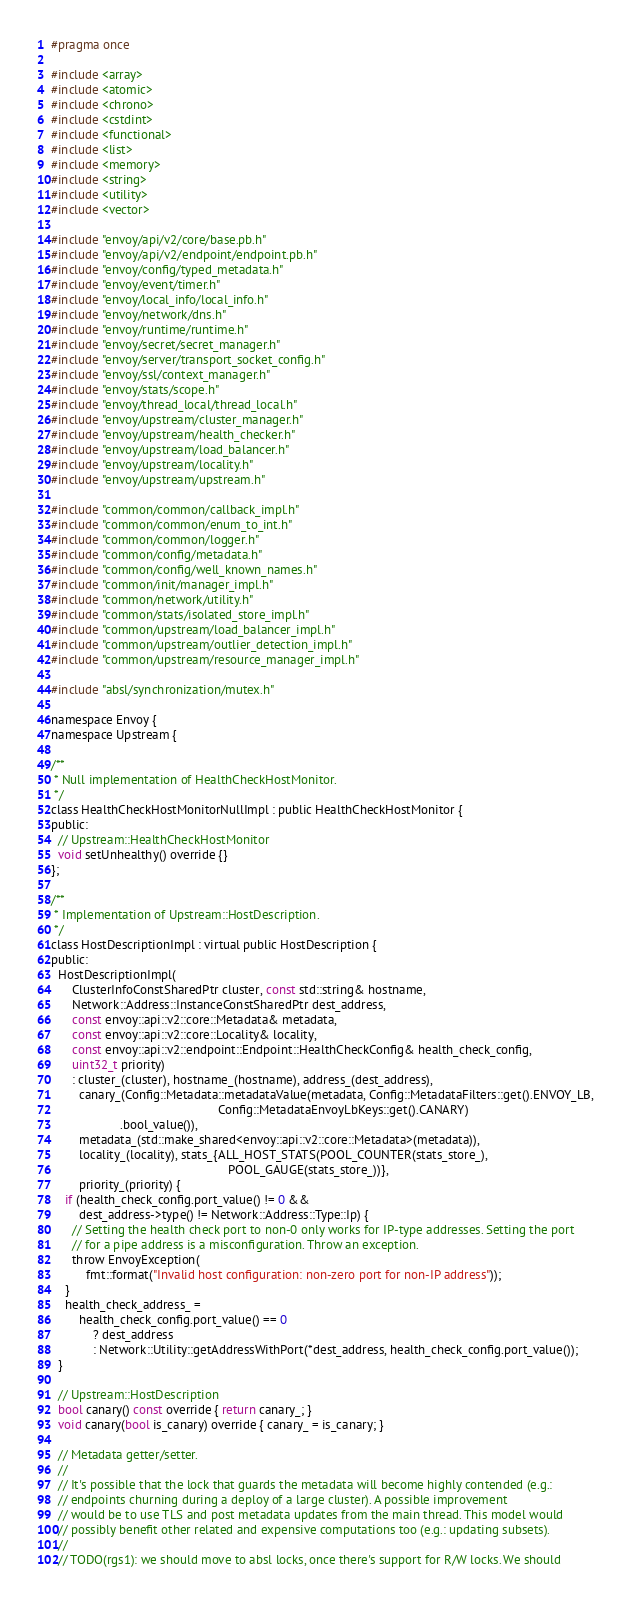<code> <loc_0><loc_0><loc_500><loc_500><_C_>#pragma once

#include <array>
#include <atomic>
#include <chrono>
#include <cstdint>
#include <functional>
#include <list>
#include <memory>
#include <string>
#include <utility>
#include <vector>

#include "envoy/api/v2/core/base.pb.h"
#include "envoy/api/v2/endpoint/endpoint.pb.h"
#include "envoy/config/typed_metadata.h"
#include "envoy/event/timer.h"
#include "envoy/local_info/local_info.h"
#include "envoy/network/dns.h"
#include "envoy/runtime/runtime.h"
#include "envoy/secret/secret_manager.h"
#include "envoy/server/transport_socket_config.h"
#include "envoy/ssl/context_manager.h"
#include "envoy/stats/scope.h"
#include "envoy/thread_local/thread_local.h"
#include "envoy/upstream/cluster_manager.h"
#include "envoy/upstream/health_checker.h"
#include "envoy/upstream/load_balancer.h"
#include "envoy/upstream/locality.h"
#include "envoy/upstream/upstream.h"

#include "common/common/callback_impl.h"
#include "common/common/enum_to_int.h"
#include "common/common/logger.h"
#include "common/config/metadata.h"
#include "common/config/well_known_names.h"
#include "common/init/manager_impl.h"
#include "common/network/utility.h"
#include "common/stats/isolated_store_impl.h"
#include "common/upstream/load_balancer_impl.h"
#include "common/upstream/outlier_detection_impl.h"
#include "common/upstream/resource_manager_impl.h"

#include "absl/synchronization/mutex.h"

namespace Envoy {
namespace Upstream {

/**
 * Null implementation of HealthCheckHostMonitor.
 */
class HealthCheckHostMonitorNullImpl : public HealthCheckHostMonitor {
public:
  // Upstream::HealthCheckHostMonitor
  void setUnhealthy() override {}
};

/**
 * Implementation of Upstream::HostDescription.
 */
class HostDescriptionImpl : virtual public HostDescription {
public:
  HostDescriptionImpl(
      ClusterInfoConstSharedPtr cluster, const std::string& hostname,
      Network::Address::InstanceConstSharedPtr dest_address,
      const envoy::api::v2::core::Metadata& metadata,
      const envoy::api::v2::core::Locality& locality,
      const envoy::api::v2::endpoint::Endpoint::HealthCheckConfig& health_check_config,
      uint32_t priority)
      : cluster_(cluster), hostname_(hostname), address_(dest_address),
        canary_(Config::Metadata::metadataValue(metadata, Config::MetadataFilters::get().ENVOY_LB,
                                                Config::MetadataEnvoyLbKeys::get().CANARY)
                    .bool_value()),
        metadata_(std::make_shared<envoy::api::v2::core::Metadata>(metadata)),
        locality_(locality), stats_{ALL_HOST_STATS(POOL_COUNTER(stats_store_),
                                                   POOL_GAUGE(stats_store_))},
        priority_(priority) {
    if (health_check_config.port_value() != 0 &&
        dest_address->type() != Network::Address::Type::Ip) {
      // Setting the health check port to non-0 only works for IP-type addresses. Setting the port
      // for a pipe address is a misconfiguration. Throw an exception.
      throw EnvoyException(
          fmt::format("Invalid host configuration: non-zero port for non-IP address"));
    }
    health_check_address_ =
        health_check_config.port_value() == 0
            ? dest_address
            : Network::Utility::getAddressWithPort(*dest_address, health_check_config.port_value());
  }

  // Upstream::HostDescription
  bool canary() const override { return canary_; }
  void canary(bool is_canary) override { canary_ = is_canary; }

  // Metadata getter/setter.
  //
  // It's possible that the lock that guards the metadata will become highly contended (e.g.:
  // endpoints churning during a deploy of a large cluster). A possible improvement
  // would be to use TLS and post metadata updates from the main thread. This model would
  // possibly benefit other related and expensive computations too (e.g.: updating subsets).
  //
  // TODO(rgs1): we should move to absl locks, once there's support for R/W locks. We should</code> 